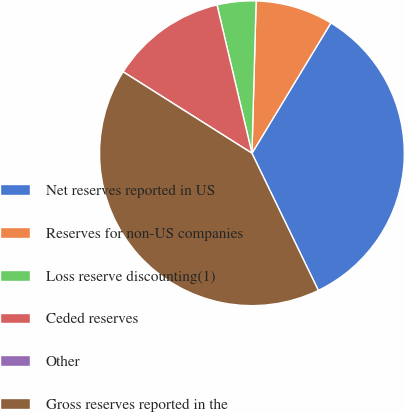<chart> <loc_0><loc_0><loc_500><loc_500><pie_chart><fcel>Net reserves reported in US<fcel>Reserves for non-US companies<fcel>Loss reserve discounting(1)<fcel>Ceded reserves<fcel>Other<fcel>Gross reserves reported in the<nl><fcel>34.16%<fcel>8.23%<fcel>4.12%<fcel>12.35%<fcel>0.0%<fcel>41.15%<nl></chart> 